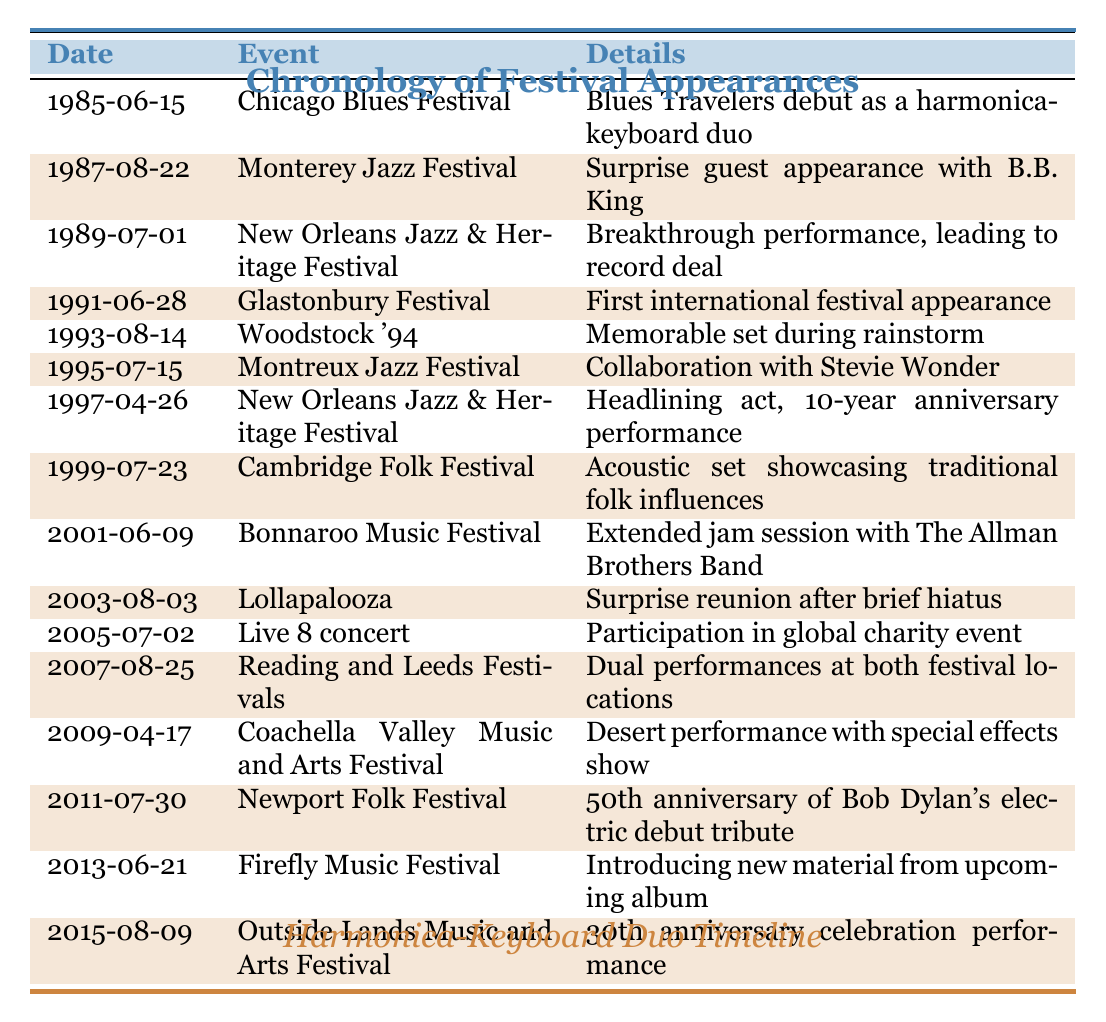What was the duo's first festival appearance? The first appearance was at the Chicago Blues Festival on June 15, 1985. This can be found by looking at the first row of the table which lists the date and event.
Answer: Chicago Blues Festival How many festival appearances were made in the 1990s? Counting the entries from 1990 to 1999, there are 6 appearances: Glastonbury Festival (1991), Woodstock '94 (1993), Montreux Jazz Festival (1995), New Orleans Jazz & Heritage Festival (1997), Cambridge Folk Festival (1999).
Answer: 6 Did the duo perform at Glastonbury Festival before or after Woodstock '94? By looking at the dates in the table, Glastonbury Festival was on June 28, 1991, which is before Woodstock '94 on August 14, 1993.
Answer: Before What is the span of years between the first and last festival appearances listed? The first appearance was in 1985 and the last in 2015. Calculating the difference, 2015 - 1985 = 30 years. This indicates they have been active in festival appearances for 30 years.
Answer: 30 years Was the performance at the Montreux Jazz Festival a collaboration? Yes, the table states that during the Montreux Jazz Festival on July 15, 1995, there was a collaboration with Stevie Wonder, indicating a special joint performance.
Answer: Yes List those festivals where the duo performed in dual locations or settings. The duo performed at Reading and Leeds Festivals on August 25, 2007, as a dual performance is noted in the details. This is the only instance of such in the table.
Answer: Reading and Leeds Festivals Between which two festivals did the duo have a surprise reunion? The surprise reunion occurred at Lollapalooza on August 3, 2003. Observing the table, this follows the Bonnaroo Music Festival on June 9, 2001, meaning the reunion came after the last appearance at Bonnaroo.
Answer: Bonnaroo and Lollapalooza How many times did the duo return to the New Orleans Jazz and Heritage Festival? They had two appearances at the New Orleans Jazz & Heritage Festival: the first was on July 1, 1989, and the return was on April 26, 1997. Summing these entries gives the total of 2 appearances.
Answer: 2 